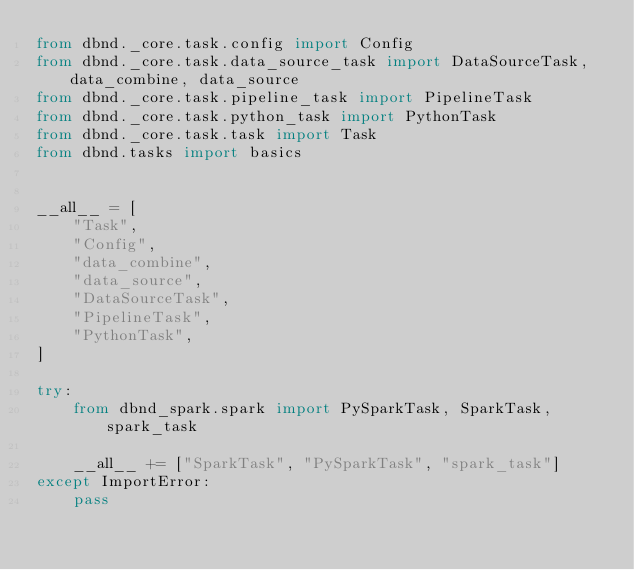Convert code to text. <code><loc_0><loc_0><loc_500><loc_500><_Python_>from dbnd._core.task.config import Config
from dbnd._core.task.data_source_task import DataSourceTask, data_combine, data_source
from dbnd._core.task.pipeline_task import PipelineTask
from dbnd._core.task.python_task import PythonTask
from dbnd._core.task.task import Task
from dbnd.tasks import basics


__all__ = [
    "Task",
    "Config",
    "data_combine",
    "data_source",
    "DataSourceTask",
    "PipelineTask",
    "PythonTask",
]

try:
    from dbnd_spark.spark import PySparkTask, SparkTask, spark_task

    __all__ += ["SparkTask", "PySparkTask", "spark_task"]
except ImportError:
    pass
</code> 